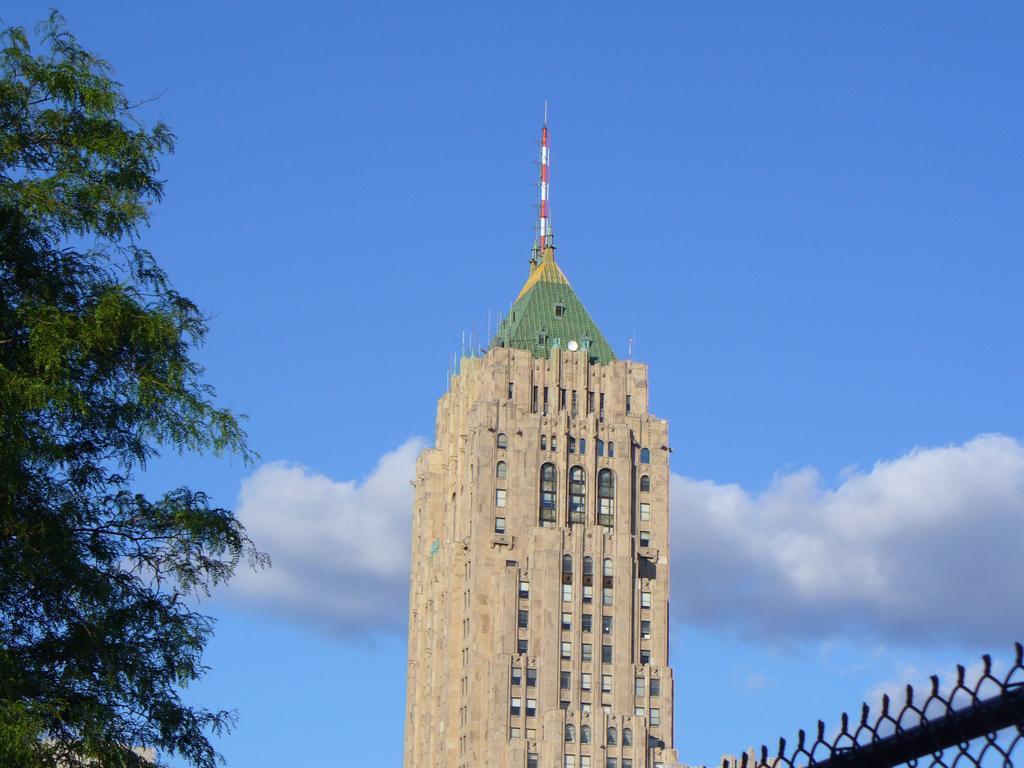Can you describe this image briefly? In this image I can see the building, windows, trees and the net fencing. The sky is in blue and white color. 